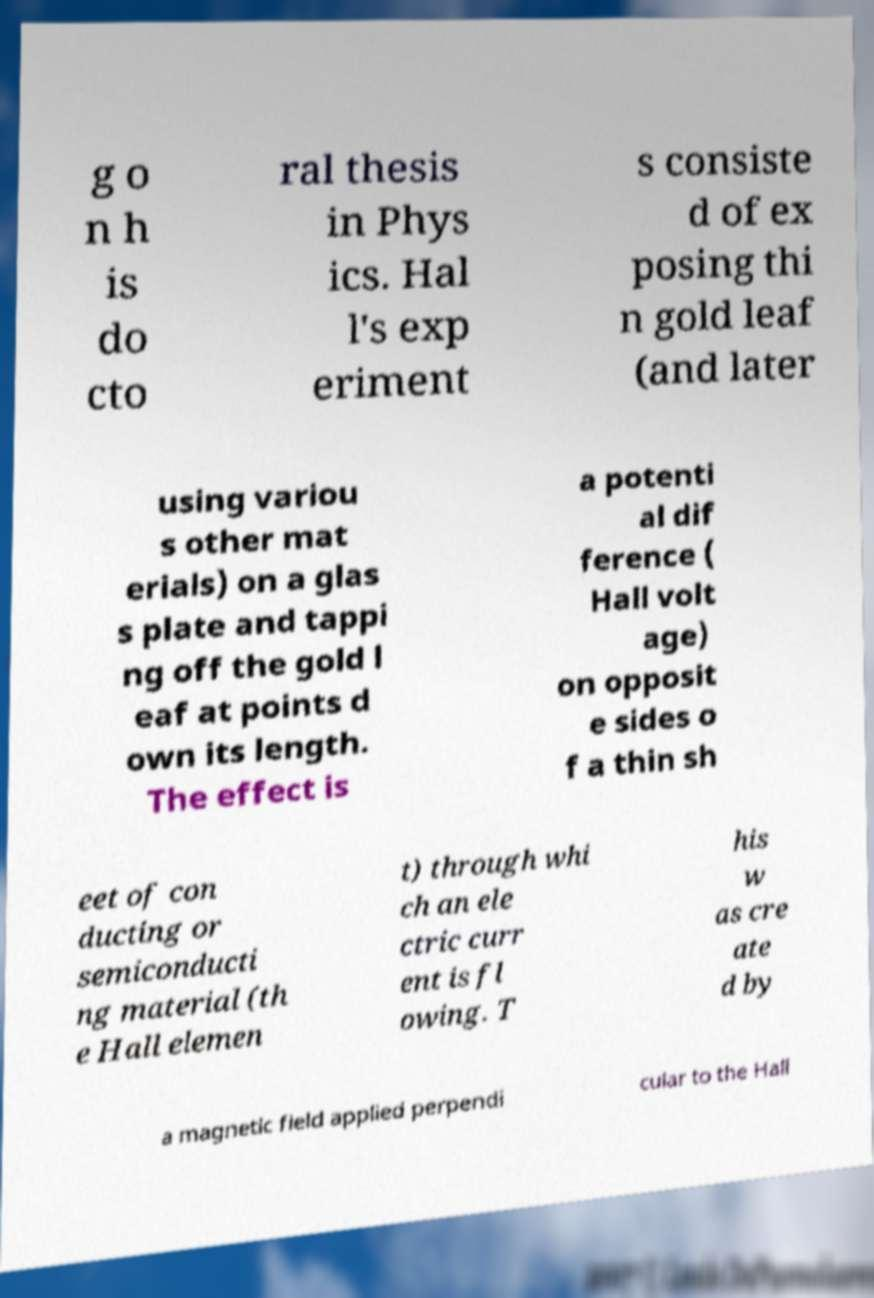Please identify and transcribe the text found in this image. g o n h is do cto ral thesis in Phys ics. Hal l's exp eriment s consiste d of ex posing thi n gold leaf (and later using variou s other mat erials) on a glas s plate and tappi ng off the gold l eaf at points d own its length. The effect is a potenti al dif ference ( Hall volt age) on opposit e sides o f a thin sh eet of con ducting or semiconducti ng material (th e Hall elemen t) through whi ch an ele ctric curr ent is fl owing. T his w as cre ate d by a magnetic field applied perpendi cular to the Hall 